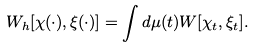<formula> <loc_0><loc_0><loc_500><loc_500>W _ { h } [ \chi ( \cdot ) , \xi ( \cdot ) ] = \int d \mu ( t ) W [ \chi _ { t } , \xi _ { t } ] .</formula> 